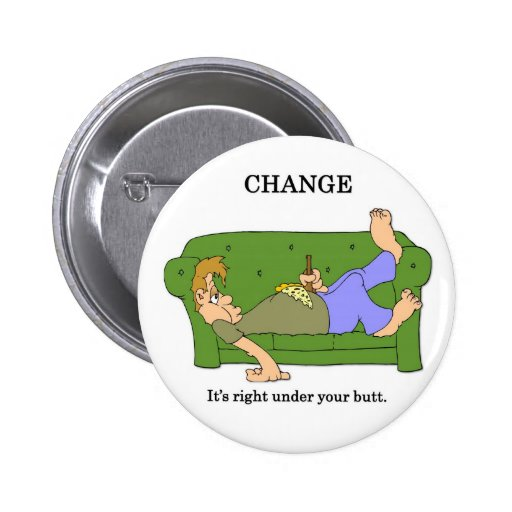Imagine the characters decide to start a new hobby together inspired by finding 'change.' What might that hobby be and how could it impact their lives? Inspired by finding 'change,' the characters decide to start a hobby of metal detecting in their local park. This hobby not only fulfills their curiosity for finding literal change but also encourages them to spend more time outdoors, engaging in physical activity. As they regularly explore the park, they uncover various forgotten coins and small trinkets, which they decide to collect and eventually donate to a local charity. This shared activity fosters a stronger bond between them and instills a sense of purpose and community involvement in their lives. 